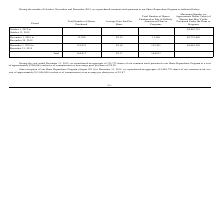According to Network 1 Technologies's financial document, How many shares did the company repurchase during the year ended December 31, 2019? According to the financial document, 335,372 shares. The relevant text states: "December 31, 2019, we repurchased an aggregate of 335,372 shares of our common stock pursuant to our Share Repurchase Program at a cost..." Also, How many shares did the company repurchase since the inception of the Share Repurchase Program? According to the financial document, 8,489,770 shares. The relevant text states: "December 31, 2019, we repurchased an aggregate of 8,489,770 shares of our common stock at a..." Also, How much did it cost to repurchase shares under the Share Repurchase Program? cost of approximately $15,906,846. The document states: "cost of approximately $15,906,846 (exclusive of commissions) or an average per share price of $1.87...." Also, can you calculate: How many shares did the company purchase prior to October 1, 2019 for 2019? Based on the calculation: 335,372 - 164,817, the result is 170555. This is based on the information: "Total 164,817 $2.17 164,817 December 31, 2019, we repurchased an aggregate of 335,372 shares of our common stock pursuant to our Share Repurchase Program at a cost..." The key data points involved are: 164,817, 335,372. Also, can you calculate: What % of total shares purchased during year ended December 31, 2019 were shares purchased during October 1, 2019 to December 31, 2019? Based on the calculation: 164,817/335,372, the result is 49.14 (percentage). This is based on the information: "Total 164,817 $2.17 164,817 December 31, 2019, we repurchased an aggregate of 335,372 shares of our common stock pursuant to our Share Repurchase Program at a cost..." The key data points involved are: 164,817, 335,372. Also, can you calculate: What % of total shares purchased since the inception of the Share Repurchase Program were shares purchased during year ended December 31, 2019? Based on the calculation: 335,372/8,489,770, the result is 3.95 (percentage). This is based on the information: "December 31, 2019, we repurchased an aggregate of 335,372 shares of our common stock pursuant to our Share Repurchase Program at a cost December 31, 2019, we repurchased an aggregate of 8,489,770 shar..." The key data points involved are: 335,372, 8,489,770. 